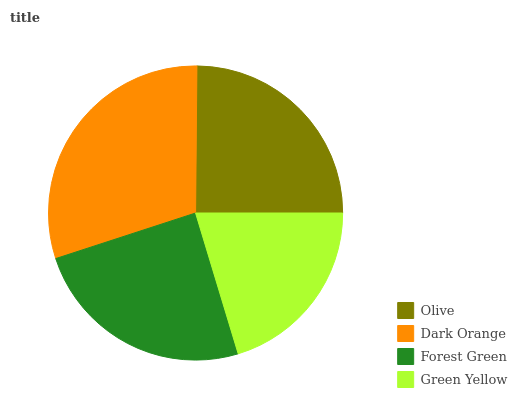Is Green Yellow the minimum?
Answer yes or no. Yes. Is Dark Orange the maximum?
Answer yes or no. Yes. Is Forest Green the minimum?
Answer yes or no. No. Is Forest Green the maximum?
Answer yes or no. No. Is Dark Orange greater than Forest Green?
Answer yes or no. Yes. Is Forest Green less than Dark Orange?
Answer yes or no. Yes. Is Forest Green greater than Dark Orange?
Answer yes or no. No. Is Dark Orange less than Forest Green?
Answer yes or no. No. Is Olive the high median?
Answer yes or no. Yes. Is Forest Green the low median?
Answer yes or no. Yes. Is Green Yellow the high median?
Answer yes or no. No. Is Green Yellow the low median?
Answer yes or no. No. 